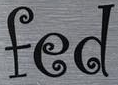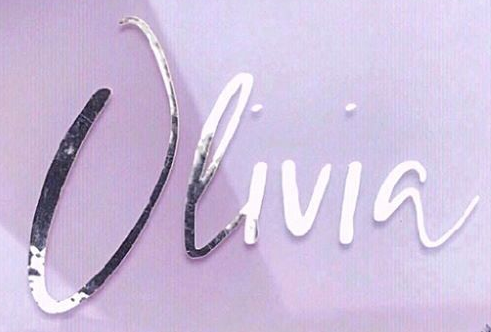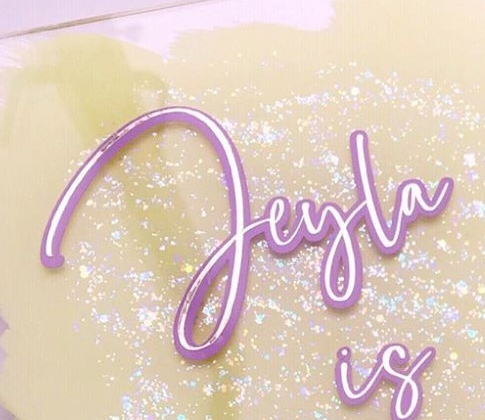What words are shown in these images in order, separated by a semicolon? fed; Olivia; Jeyla 